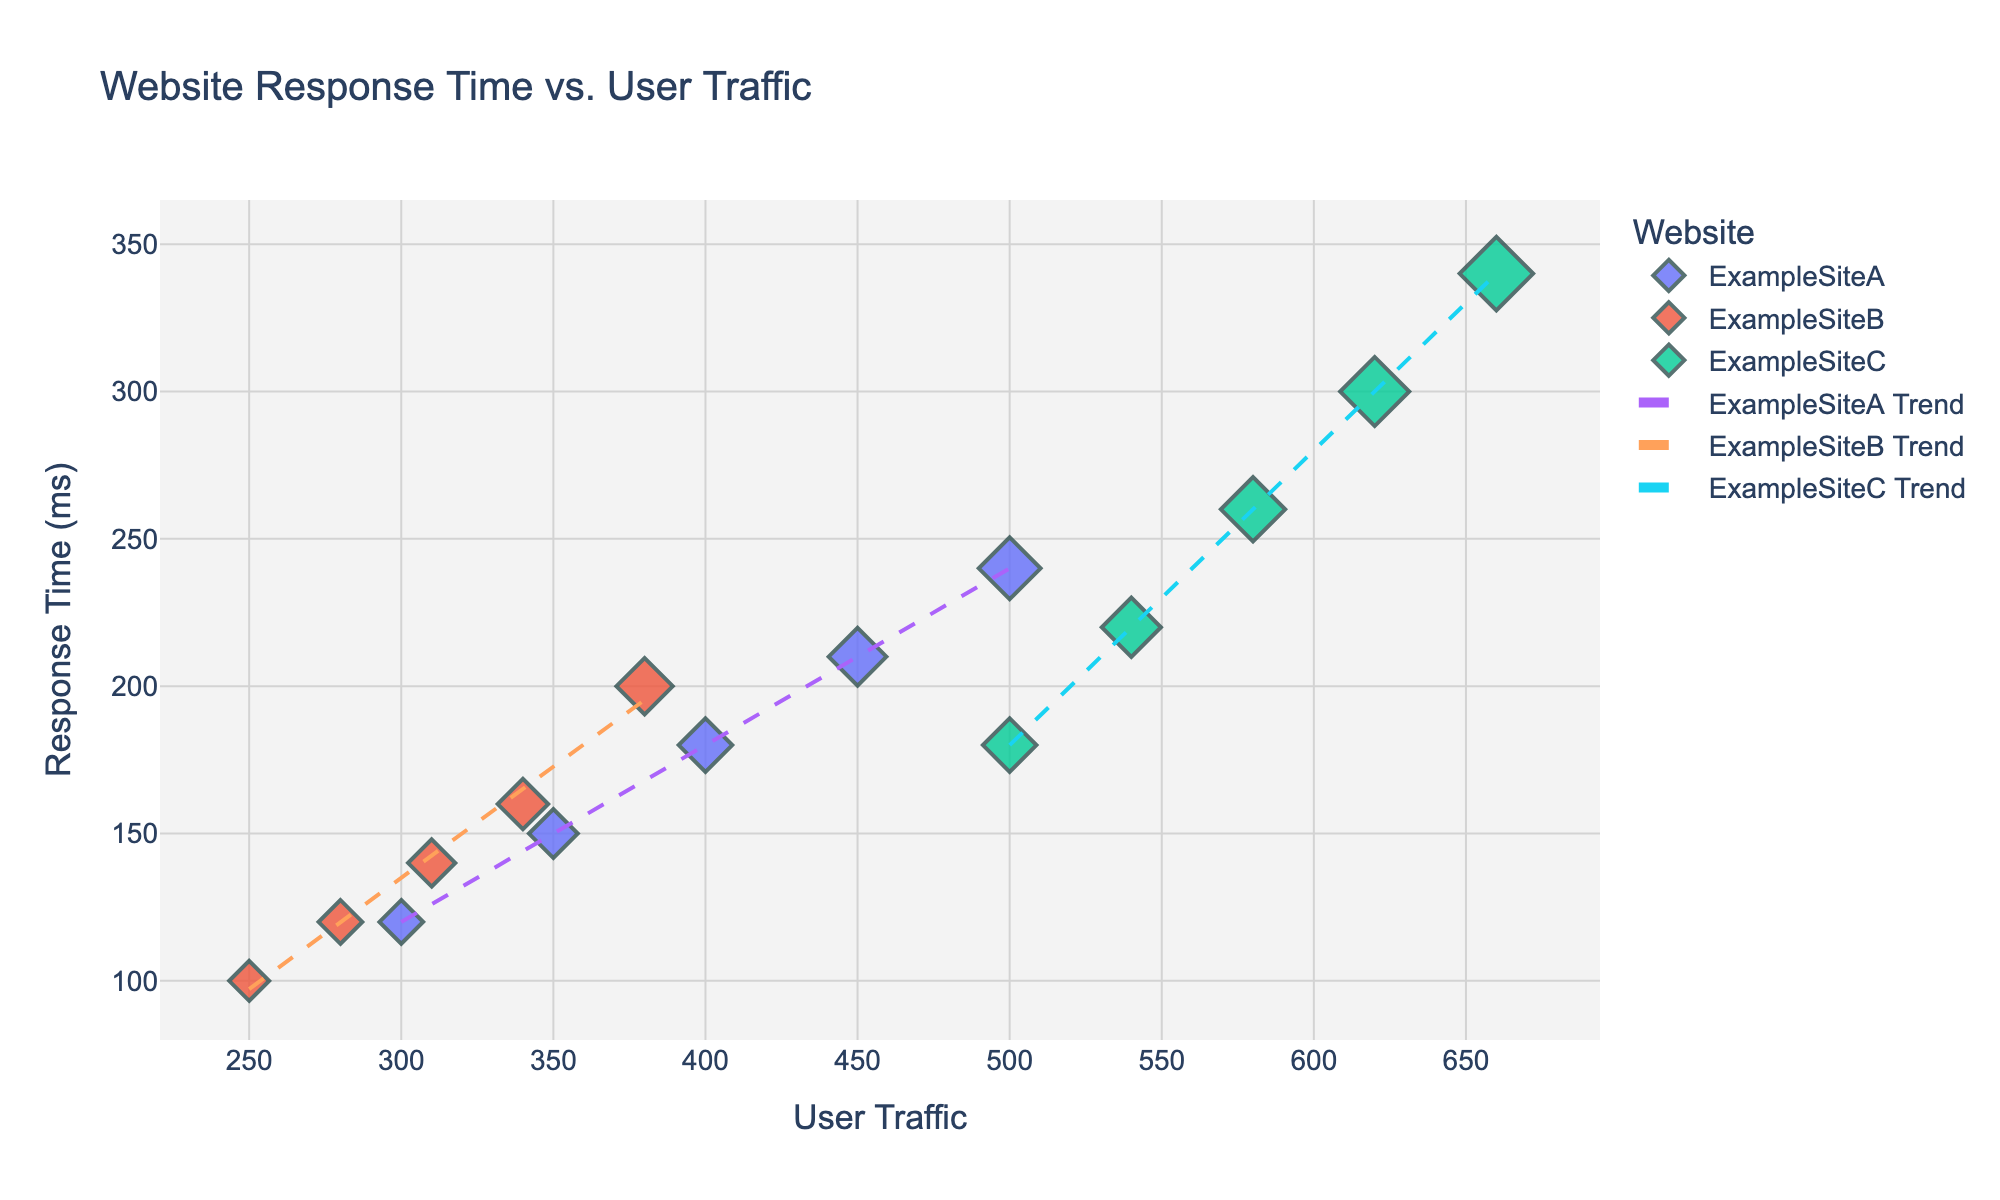what is the title of the figure? The title of the figure is located at the top center above the plot. It should describe the relationship between the two variables being visualized.
Answer: Website Response Time vs. User Traffic how many websites are included in the figure? The number of unique websites can be identified by looking at the legend on the right side of the plot, where each website is represented by a different color.
Answer: 3 which website has the highest response time at the highest user traffic? To find the website with the highest response time at the peak of user traffic, locate the data point with the highest user traffic on the x-axis and check the corresponding response time and website color.
Answer: ExampleSiteC compare the trend lines of ExampleSiteA and ExampleSiteC, which one has a steeper slope? By observing the angle of inclination of the trend lines, the steeper slope indicates a greater rate of change in response time with respect to user traffic. The trend line of the website with the higher slope will be more angled.
Answer: ExampleSiteC what is the approximate response time for ExampleSiteB at 310 users? On the x-axis, find 310 users and then move vertically to intersect with ExampleSiteB's data points, then horizontally to find the corresponding response time on the y-axis.
Answer: 140 ms how does the response time of ExampleSiteC change with increasing user traffic? The trend line for ExampleSiteC shows the change; a steeper upward slope indicates a substantial increase in response time as user traffic increases.
Answer: It increases significantly which website demonstrates the least variability in response time across different user traffic levels? The website with data points closest to its trend line and the smallest relative increase in response time as user traffic increases demonstrates the least variability.
Answer: ExampleSiteB at what user traffic level does ExampleSiteA start to show a significant increase in response time? Observe the x-axis for ExampleSiteA's data points and identify the traffic level where response times start rising sharply.
Answer: Around 400 users what can be inferred about the relationship between user traffic and response time across all websites? By examining the trend lines for all websites, you can infer whether the relationship is linear, exponential, or another form, based on the general shape and direction.
Answer: Response time increases with user traffic is there any overlap in the user traffic range for different websites? Check the x-axis range for data points of each website to determine if there's a shared user traffic range where multiple websites have data points plotted.
Answer: Yes 